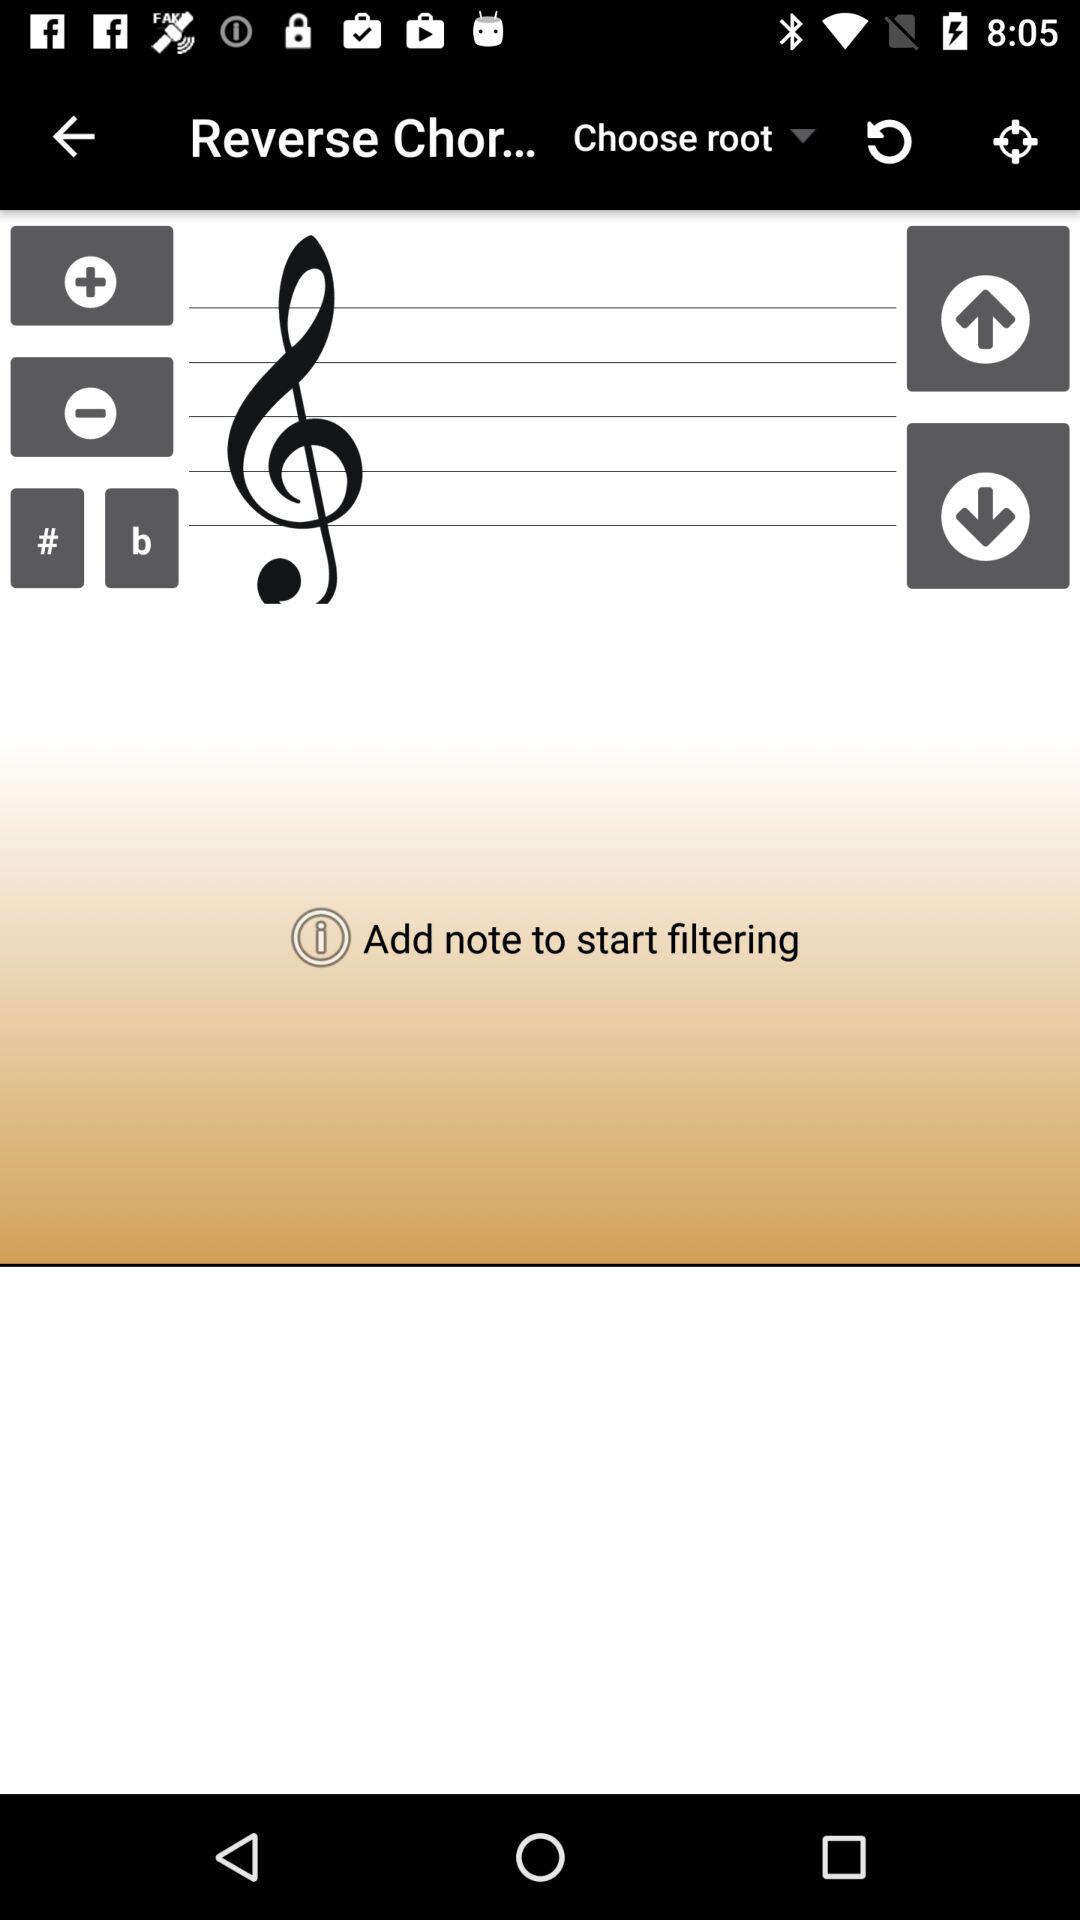Why Note's are added?
When the provided information is insufficient, respond with <no answer>. <no answer> 